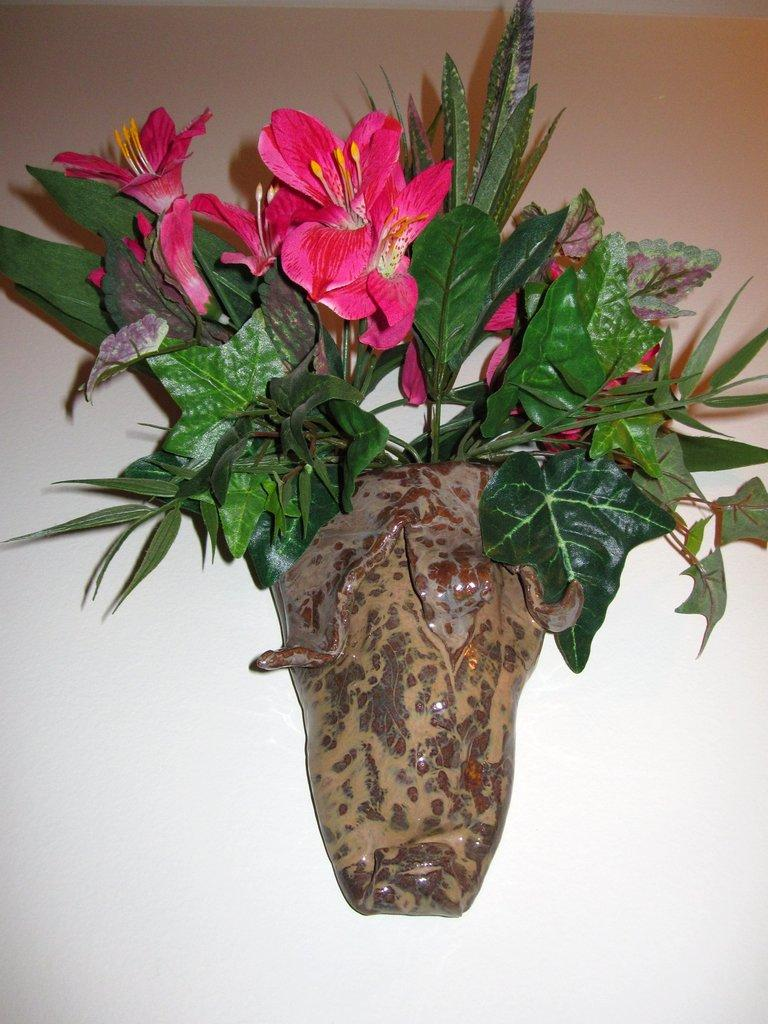What type of plant is visible in the image? There are flowers in a potted plant in the image. Can you describe the flowers in the potted plant? The flowers are not described in the provided facts, so we cannot provide specific details about their appearance. What is the container for the flowers in the image? The flowers are in a potted plant. What type of club can be seen in the image? There is no club present in the image; it features a potted plant with flowers. Is there a recess in the image where the flowers are growing? The provided facts do not mention a recess, and the image only shows a potted plant with flowers. 